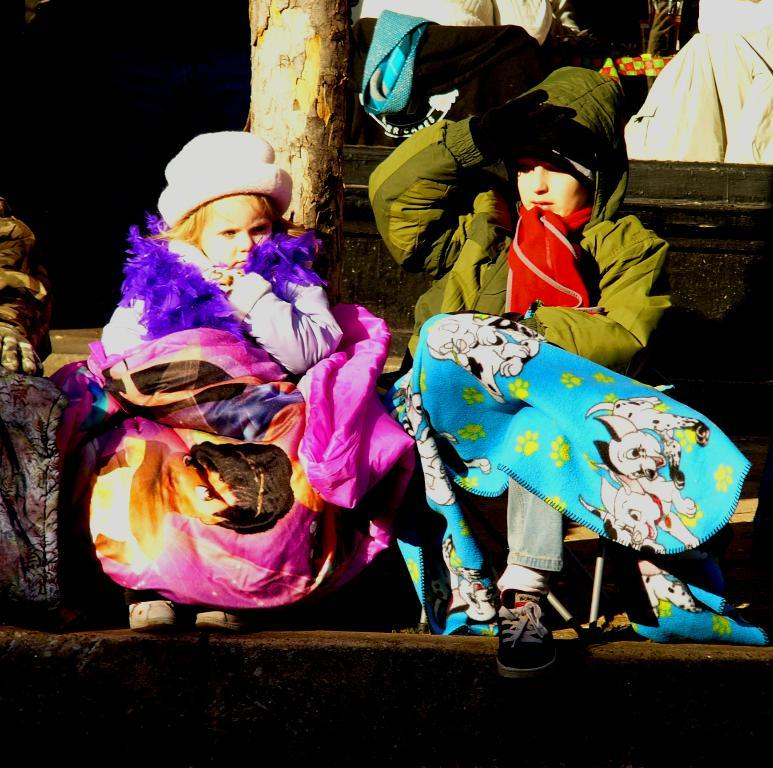How many girls are in the image? There are two girls in the image. What are the girls wearing on their upper bodies? The girls are wearing jackets. What are the girls wearing on their heads? The girls are wearing caps on their heads. What are the girls wearing on their hands? The girls are wearing gloves on their hands. Where are the girls sitting in the image? The girls are sitting on the stairs. What are the girls holding in the image? The girls are holding bags. What can be seen in the background of the image? There is a tree trunk visible in the background of the image. What type of brass instrument is the girls playing in the image? There is no brass instrument present in the image; the girls are wearing jackets, caps, and gloves, and are sitting on the stairs holding bags. 